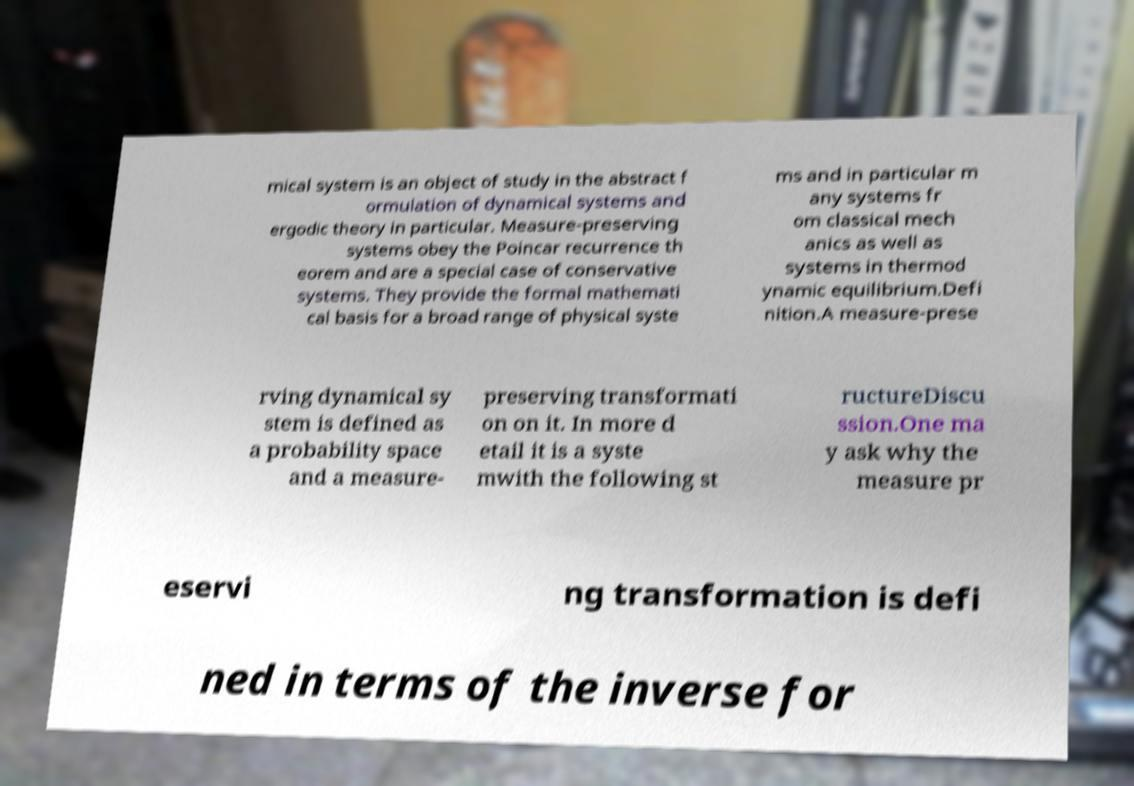For documentation purposes, I need the text within this image transcribed. Could you provide that? mical system is an object of study in the abstract f ormulation of dynamical systems and ergodic theory in particular. Measure-preserving systems obey the Poincar recurrence th eorem and are a special case of conservative systems. They provide the formal mathemati cal basis for a broad range of physical syste ms and in particular m any systems fr om classical mech anics as well as systems in thermod ynamic equilibrium.Defi nition.A measure-prese rving dynamical sy stem is defined as a probability space and a measure- preserving transformati on on it. In more d etail it is a syste mwith the following st ructureDiscu ssion.One ma y ask why the measure pr eservi ng transformation is defi ned in terms of the inverse for 